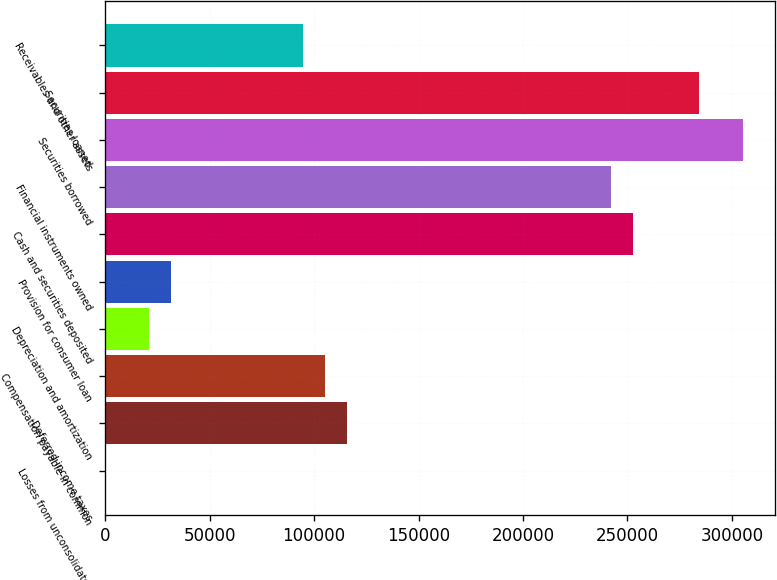Convert chart. <chart><loc_0><loc_0><loc_500><loc_500><bar_chart><fcel>Losses from unconsolidated<fcel>Deferred income taxes<fcel>Compensation payable in common<fcel>Depreciation and amortization<fcel>Provision for consumer loan<fcel>Cash and securities deposited<fcel>Financial instruments owned<fcel>Securities borrowed<fcel>Securities loaned<fcel>Receivables and other assets<nl><fcel>47<fcel>115892<fcel>105361<fcel>21109.8<fcel>31641.2<fcel>252801<fcel>242269<fcel>305458<fcel>284395<fcel>94829.6<nl></chart> 